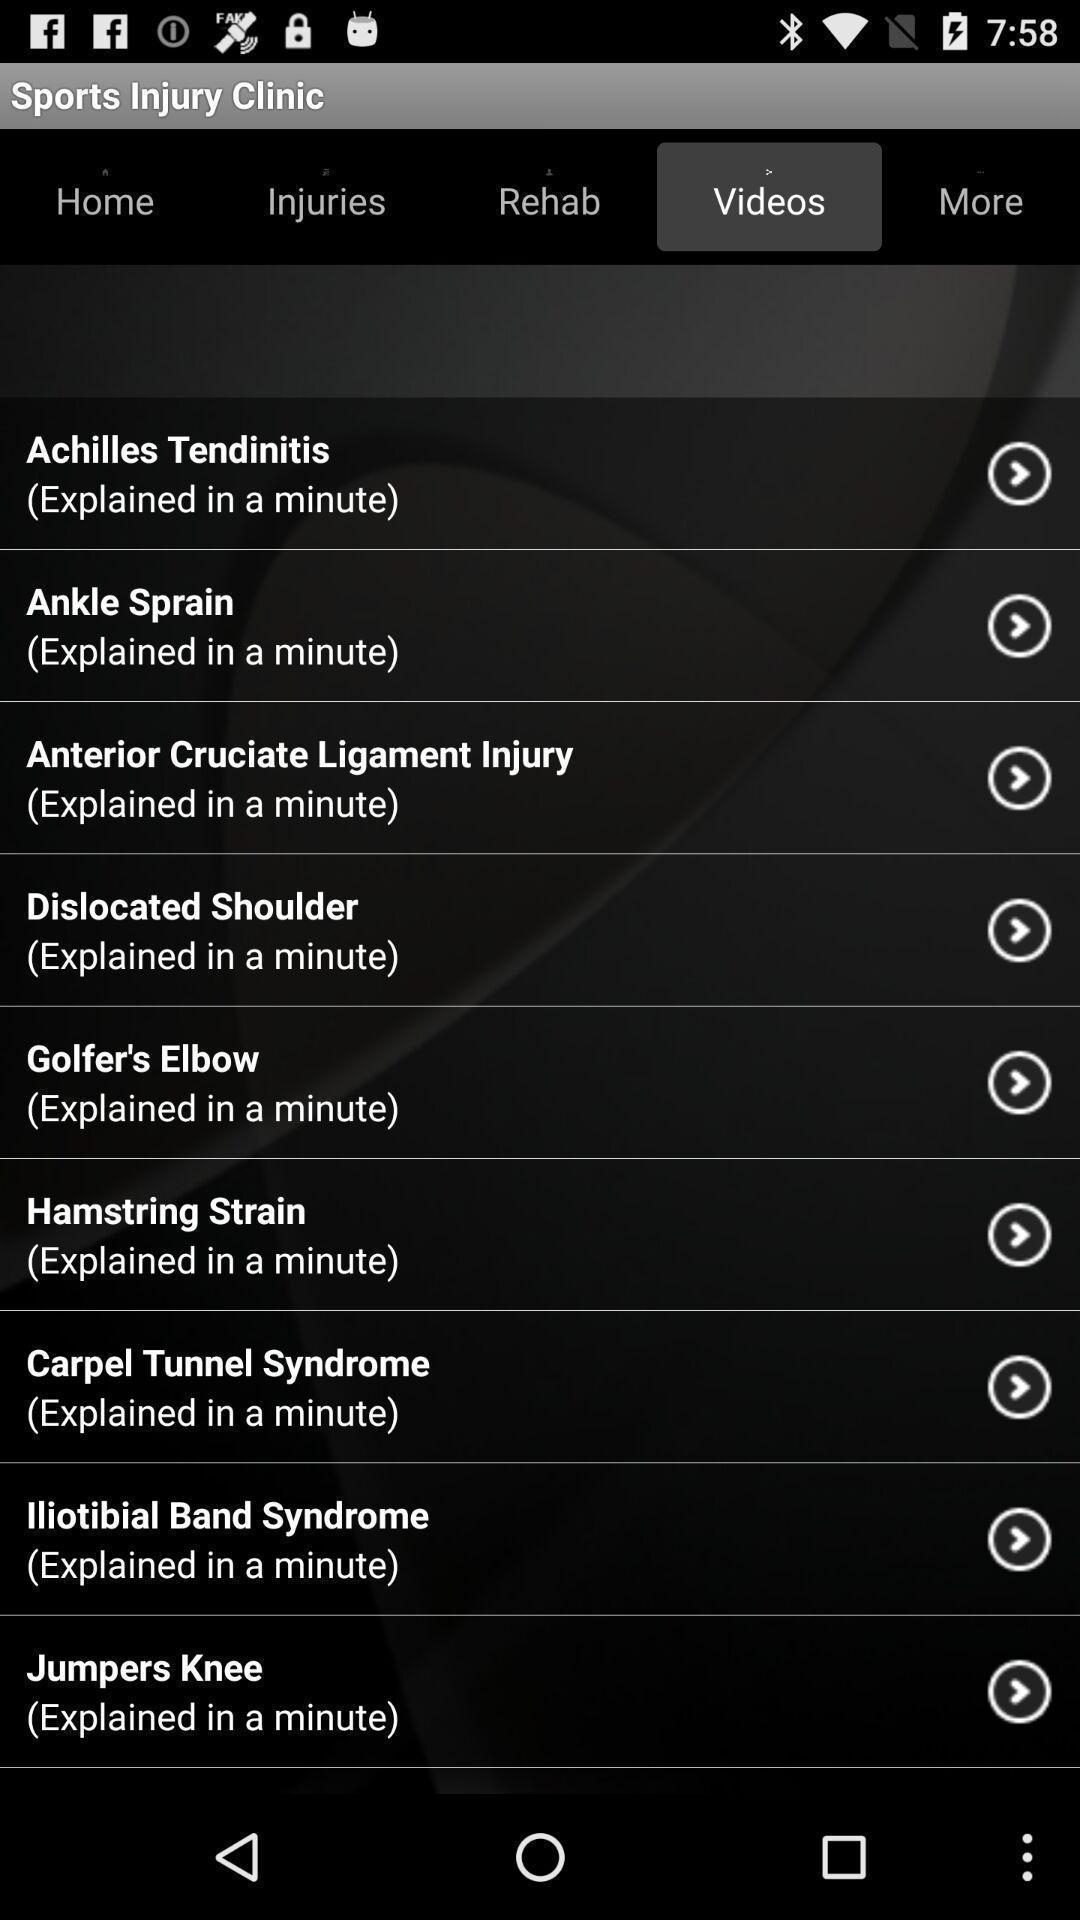Provide a detailed account of this screenshot. Videos list showing in this page. 